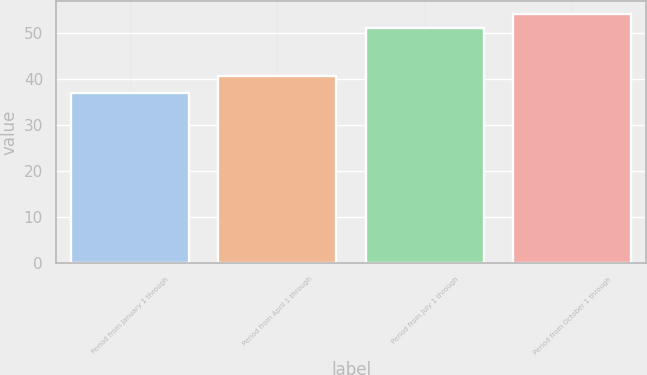<chart> <loc_0><loc_0><loc_500><loc_500><bar_chart><fcel>Period from January 1 through<fcel>Period from April 1 through<fcel>Period from July 1 through<fcel>Period from October 1 through<nl><fcel>37<fcel>40.78<fcel>51.12<fcel>54.25<nl></chart> 